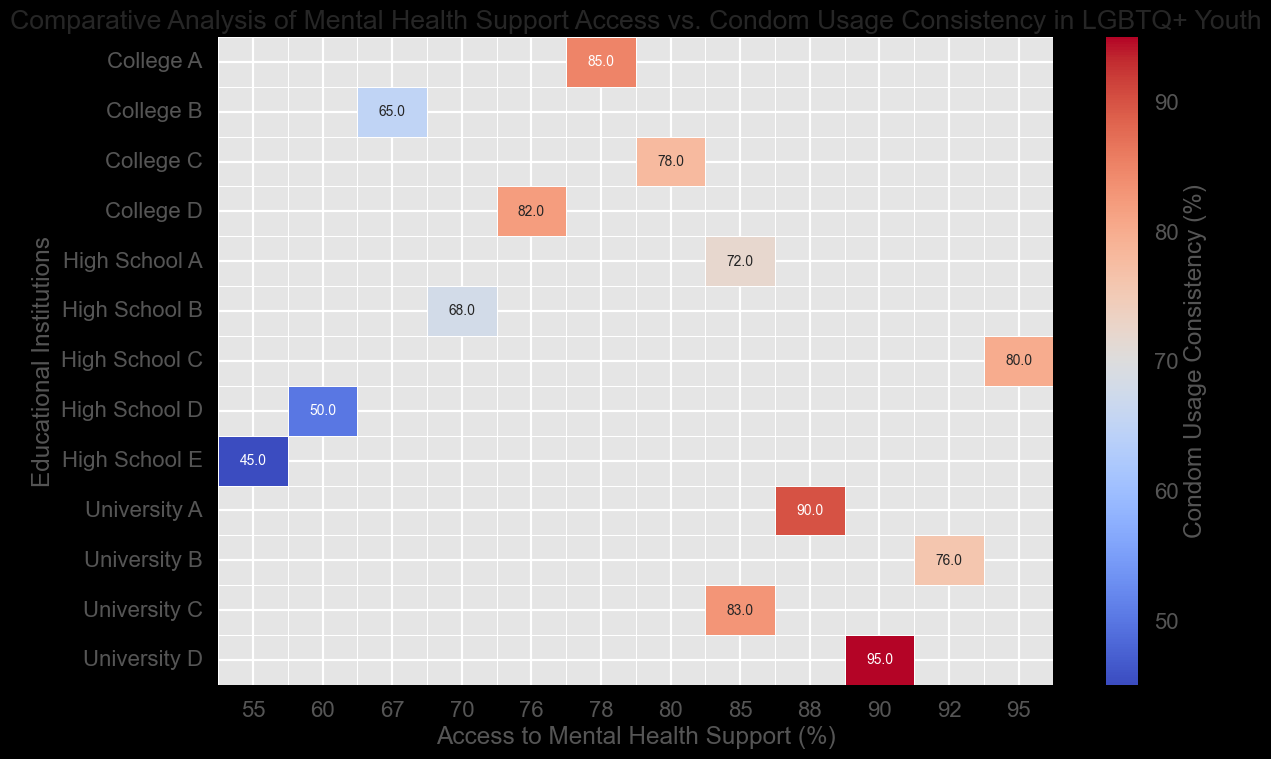Which institution has the highest condom usage consistency? Identify the highest value in the Condom Usage Consistency column and match it with its corresponding institution.
Answer: University D How does access to mental health support compare between High School A and High School E? Look at the mental health support percentage for each school and compare the values.
Answer: High School A: 85%, High School E: 55% Which educational institution has the lowest access to mental health support, and what is its condom usage consistency? Locate the institution with the lowest percentage in the Access to Mental Health Support column and check its corresponding condom usage percentage.
Answer: High School E: 55%, Condom Usage Consistency: 45% Is there any institution where both access to mental health support and condom usage consistency are greater than 90%? Search for any institution meeting this criterion in both columns.
Answer: University D (Access to Mental Health: 90%, Condom Usage Consistency: 95%) Comparing all universities, which university has the highest and lowest condom usage consistency? Isolate the universities and compare their condom usage values to identify the highest and lowest.
Answer: Highest: University D (95%), Lowest: University B (76%) What is the average condom usage consistency among all high schools listed? Sum up the condom usage values for all high schools and divide by the number of high schools. (72 + 68 + 80 + 50 + 45) = 315, then 315 / 5.
Answer: 63% Do any colleges have a higher condom usage consistency than University A? If so, which ones and by how much? Compare condom usage consistency percentages of all colleges with that of University A (90%) and list the differences.
Answer: College A: Yes, by 5% (85%), College D: Yes, by 2% (82%) Which institution shows the largest gap between access to mental health support and condom usage consistency? Calculate the absolute difference for each institution and identify the maximum value.
Answer: High School E (Difference: 10%) Which institution has an access to mental health support percentage within 5% of 80% and what is its condom usage consistency? Search for institutions where the mental health support percentage is between 75% and 85% and note their condom usage consistency.
Answer: College C (Access to Mental Health: 80%, Condom Usage Consistency: 78%) 